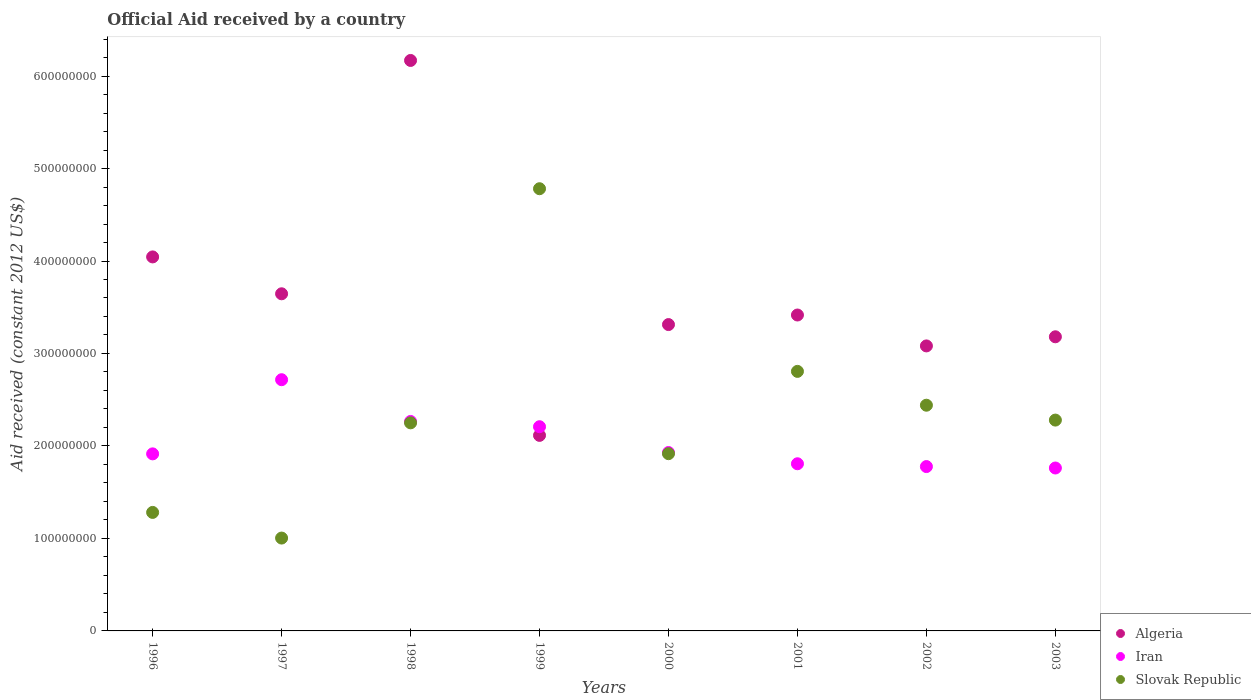How many different coloured dotlines are there?
Provide a short and direct response. 3. What is the net official aid received in Slovak Republic in 2003?
Your answer should be compact. 2.28e+08. Across all years, what is the maximum net official aid received in Slovak Republic?
Make the answer very short. 4.78e+08. Across all years, what is the minimum net official aid received in Algeria?
Your response must be concise. 2.11e+08. In which year was the net official aid received in Slovak Republic maximum?
Provide a succinct answer. 1999. What is the total net official aid received in Iran in the graph?
Offer a terse response. 1.64e+09. What is the difference between the net official aid received in Algeria in 1997 and that in 1999?
Provide a succinct answer. 1.53e+08. What is the difference between the net official aid received in Algeria in 1998 and the net official aid received in Iran in 2001?
Your response must be concise. 4.36e+08. What is the average net official aid received in Iran per year?
Offer a terse response. 2.05e+08. In the year 1998, what is the difference between the net official aid received in Algeria and net official aid received in Iran?
Offer a terse response. 3.90e+08. What is the ratio of the net official aid received in Algeria in 1998 to that in 2001?
Offer a terse response. 1.81. Is the net official aid received in Algeria in 1996 less than that in 2000?
Keep it short and to the point. No. What is the difference between the highest and the second highest net official aid received in Slovak Republic?
Provide a succinct answer. 1.98e+08. What is the difference between the highest and the lowest net official aid received in Algeria?
Provide a succinct answer. 4.05e+08. Is the sum of the net official aid received in Slovak Republic in 1998 and 2002 greater than the maximum net official aid received in Iran across all years?
Provide a short and direct response. Yes. Is the net official aid received in Slovak Republic strictly less than the net official aid received in Algeria over the years?
Ensure brevity in your answer.  No. Are the values on the major ticks of Y-axis written in scientific E-notation?
Ensure brevity in your answer.  No. How many legend labels are there?
Make the answer very short. 3. How are the legend labels stacked?
Offer a terse response. Vertical. What is the title of the graph?
Your answer should be very brief. Official Aid received by a country. What is the label or title of the Y-axis?
Keep it short and to the point. Aid received (constant 2012 US$). What is the Aid received (constant 2012 US$) in Algeria in 1996?
Your response must be concise. 4.04e+08. What is the Aid received (constant 2012 US$) of Iran in 1996?
Provide a short and direct response. 1.91e+08. What is the Aid received (constant 2012 US$) of Slovak Republic in 1996?
Your answer should be very brief. 1.28e+08. What is the Aid received (constant 2012 US$) of Algeria in 1997?
Give a very brief answer. 3.65e+08. What is the Aid received (constant 2012 US$) of Iran in 1997?
Give a very brief answer. 2.72e+08. What is the Aid received (constant 2012 US$) in Slovak Republic in 1997?
Give a very brief answer. 1.00e+08. What is the Aid received (constant 2012 US$) of Algeria in 1998?
Ensure brevity in your answer.  6.17e+08. What is the Aid received (constant 2012 US$) of Iran in 1998?
Keep it short and to the point. 2.27e+08. What is the Aid received (constant 2012 US$) of Slovak Republic in 1998?
Provide a succinct answer. 2.25e+08. What is the Aid received (constant 2012 US$) of Algeria in 1999?
Offer a terse response. 2.11e+08. What is the Aid received (constant 2012 US$) of Iran in 1999?
Give a very brief answer. 2.21e+08. What is the Aid received (constant 2012 US$) of Slovak Republic in 1999?
Your answer should be very brief. 4.78e+08. What is the Aid received (constant 2012 US$) in Algeria in 2000?
Offer a terse response. 3.31e+08. What is the Aid received (constant 2012 US$) in Iran in 2000?
Your response must be concise. 1.93e+08. What is the Aid received (constant 2012 US$) of Slovak Republic in 2000?
Make the answer very short. 1.92e+08. What is the Aid received (constant 2012 US$) in Algeria in 2001?
Your answer should be very brief. 3.42e+08. What is the Aid received (constant 2012 US$) in Iran in 2001?
Offer a terse response. 1.81e+08. What is the Aid received (constant 2012 US$) of Slovak Republic in 2001?
Make the answer very short. 2.81e+08. What is the Aid received (constant 2012 US$) in Algeria in 2002?
Provide a succinct answer. 3.08e+08. What is the Aid received (constant 2012 US$) in Iran in 2002?
Keep it short and to the point. 1.78e+08. What is the Aid received (constant 2012 US$) in Slovak Republic in 2002?
Make the answer very short. 2.44e+08. What is the Aid received (constant 2012 US$) of Algeria in 2003?
Ensure brevity in your answer.  3.18e+08. What is the Aid received (constant 2012 US$) in Iran in 2003?
Provide a succinct answer. 1.76e+08. What is the Aid received (constant 2012 US$) in Slovak Republic in 2003?
Ensure brevity in your answer.  2.28e+08. Across all years, what is the maximum Aid received (constant 2012 US$) of Algeria?
Ensure brevity in your answer.  6.17e+08. Across all years, what is the maximum Aid received (constant 2012 US$) of Iran?
Give a very brief answer. 2.72e+08. Across all years, what is the maximum Aid received (constant 2012 US$) in Slovak Republic?
Provide a succinct answer. 4.78e+08. Across all years, what is the minimum Aid received (constant 2012 US$) of Algeria?
Your answer should be compact. 2.11e+08. Across all years, what is the minimum Aid received (constant 2012 US$) of Iran?
Offer a terse response. 1.76e+08. Across all years, what is the minimum Aid received (constant 2012 US$) of Slovak Republic?
Your response must be concise. 1.00e+08. What is the total Aid received (constant 2012 US$) in Algeria in the graph?
Your response must be concise. 2.90e+09. What is the total Aid received (constant 2012 US$) in Iran in the graph?
Your answer should be compact. 1.64e+09. What is the total Aid received (constant 2012 US$) in Slovak Republic in the graph?
Ensure brevity in your answer.  1.88e+09. What is the difference between the Aid received (constant 2012 US$) in Algeria in 1996 and that in 1997?
Ensure brevity in your answer.  3.99e+07. What is the difference between the Aid received (constant 2012 US$) of Iran in 1996 and that in 1997?
Provide a short and direct response. -8.02e+07. What is the difference between the Aid received (constant 2012 US$) of Slovak Republic in 1996 and that in 1997?
Your answer should be compact. 2.77e+07. What is the difference between the Aid received (constant 2012 US$) in Algeria in 1996 and that in 1998?
Offer a very short reply. -2.12e+08. What is the difference between the Aid received (constant 2012 US$) in Iran in 1996 and that in 1998?
Offer a terse response. -3.51e+07. What is the difference between the Aid received (constant 2012 US$) in Slovak Republic in 1996 and that in 1998?
Make the answer very short. -9.69e+07. What is the difference between the Aid received (constant 2012 US$) in Algeria in 1996 and that in 1999?
Provide a short and direct response. 1.93e+08. What is the difference between the Aid received (constant 2012 US$) in Iran in 1996 and that in 1999?
Ensure brevity in your answer.  -2.94e+07. What is the difference between the Aid received (constant 2012 US$) in Slovak Republic in 1996 and that in 1999?
Keep it short and to the point. -3.50e+08. What is the difference between the Aid received (constant 2012 US$) in Algeria in 1996 and that in 2000?
Your answer should be compact. 7.32e+07. What is the difference between the Aid received (constant 2012 US$) in Iran in 1996 and that in 2000?
Provide a succinct answer. -1.48e+06. What is the difference between the Aid received (constant 2012 US$) in Slovak Republic in 1996 and that in 2000?
Give a very brief answer. -6.35e+07. What is the difference between the Aid received (constant 2012 US$) in Algeria in 1996 and that in 2001?
Make the answer very short. 6.28e+07. What is the difference between the Aid received (constant 2012 US$) of Iran in 1996 and that in 2001?
Make the answer very short. 1.07e+07. What is the difference between the Aid received (constant 2012 US$) of Slovak Republic in 1996 and that in 2001?
Your response must be concise. -1.53e+08. What is the difference between the Aid received (constant 2012 US$) of Algeria in 1996 and that in 2002?
Your response must be concise. 9.62e+07. What is the difference between the Aid received (constant 2012 US$) in Iran in 1996 and that in 2002?
Your answer should be very brief. 1.37e+07. What is the difference between the Aid received (constant 2012 US$) of Slovak Republic in 1996 and that in 2002?
Your response must be concise. -1.16e+08. What is the difference between the Aid received (constant 2012 US$) in Algeria in 1996 and that in 2003?
Offer a terse response. 8.64e+07. What is the difference between the Aid received (constant 2012 US$) of Iran in 1996 and that in 2003?
Ensure brevity in your answer.  1.53e+07. What is the difference between the Aid received (constant 2012 US$) in Slovak Republic in 1996 and that in 2003?
Provide a succinct answer. -9.98e+07. What is the difference between the Aid received (constant 2012 US$) in Algeria in 1997 and that in 1998?
Ensure brevity in your answer.  -2.52e+08. What is the difference between the Aid received (constant 2012 US$) in Iran in 1997 and that in 1998?
Provide a short and direct response. 4.51e+07. What is the difference between the Aid received (constant 2012 US$) of Slovak Republic in 1997 and that in 1998?
Provide a succinct answer. -1.25e+08. What is the difference between the Aid received (constant 2012 US$) of Algeria in 1997 and that in 1999?
Your response must be concise. 1.53e+08. What is the difference between the Aid received (constant 2012 US$) in Iran in 1997 and that in 1999?
Ensure brevity in your answer.  5.08e+07. What is the difference between the Aid received (constant 2012 US$) in Slovak Republic in 1997 and that in 1999?
Ensure brevity in your answer.  -3.78e+08. What is the difference between the Aid received (constant 2012 US$) in Algeria in 1997 and that in 2000?
Offer a very short reply. 3.33e+07. What is the difference between the Aid received (constant 2012 US$) of Iran in 1997 and that in 2000?
Provide a succinct answer. 7.87e+07. What is the difference between the Aid received (constant 2012 US$) in Slovak Republic in 1997 and that in 2000?
Your answer should be compact. -9.12e+07. What is the difference between the Aid received (constant 2012 US$) in Algeria in 1997 and that in 2001?
Keep it short and to the point. 2.30e+07. What is the difference between the Aid received (constant 2012 US$) in Iran in 1997 and that in 2001?
Offer a very short reply. 9.09e+07. What is the difference between the Aid received (constant 2012 US$) of Slovak Republic in 1997 and that in 2001?
Ensure brevity in your answer.  -1.80e+08. What is the difference between the Aid received (constant 2012 US$) of Algeria in 1997 and that in 2002?
Keep it short and to the point. 5.64e+07. What is the difference between the Aid received (constant 2012 US$) in Iran in 1997 and that in 2002?
Your answer should be compact. 9.39e+07. What is the difference between the Aid received (constant 2012 US$) of Slovak Republic in 1997 and that in 2002?
Make the answer very short. -1.44e+08. What is the difference between the Aid received (constant 2012 US$) in Algeria in 1997 and that in 2003?
Ensure brevity in your answer.  4.65e+07. What is the difference between the Aid received (constant 2012 US$) in Iran in 1997 and that in 2003?
Ensure brevity in your answer.  9.55e+07. What is the difference between the Aid received (constant 2012 US$) in Slovak Republic in 1997 and that in 2003?
Offer a very short reply. -1.28e+08. What is the difference between the Aid received (constant 2012 US$) of Algeria in 1998 and that in 1999?
Offer a very short reply. 4.05e+08. What is the difference between the Aid received (constant 2012 US$) in Iran in 1998 and that in 1999?
Your response must be concise. 5.70e+06. What is the difference between the Aid received (constant 2012 US$) of Slovak Republic in 1998 and that in 1999?
Your answer should be very brief. -2.53e+08. What is the difference between the Aid received (constant 2012 US$) of Algeria in 1998 and that in 2000?
Provide a succinct answer. 2.86e+08. What is the difference between the Aid received (constant 2012 US$) in Iran in 1998 and that in 2000?
Provide a short and direct response. 3.36e+07. What is the difference between the Aid received (constant 2012 US$) in Slovak Republic in 1998 and that in 2000?
Provide a short and direct response. 3.33e+07. What is the difference between the Aid received (constant 2012 US$) of Algeria in 1998 and that in 2001?
Your answer should be compact. 2.75e+08. What is the difference between the Aid received (constant 2012 US$) of Iran in 1998 and that in 2001?
Ensure brevity in your answer.  4.58e+07. What is the difference between the Aid received (constant 2012 US$) of Slovak Republic in 1998 and that in 2001?
Offer a terse response. -5.56e+07. What is the difference between the Aid received (constant 2012 US$) of Algeria in 1998 and that in 2002?
Keep it short and to the point. 3.09e+08. What is the difference between the Aid received (constant 2012 US$) in Iran in 1998 and that in 2002?
Offer a very short reply. 4.88e+07. What is the difference between the Aid received (constant 2012 US$) in Slovak Republic in 1998 and that in 2002?
Ensure brevity in your answer.  -1.91e+07. What is the difference between the Aid received (constant 2012 US$) in Algeria in 1998 and that in 2003?
Offer a very short reply. 2.99e+08. What is the difference between the Aid received (constant 2012 US$) of Iran in 1998 and that in 2003?
Provide a short and direct response. 5.03e+07. What is the difference between the Aid received (constant 2012 US$) of Slovak Republic in 1998 and that in 2003?
Give a very brief answer. -2.98e+06. What is the difference between the Aid received (constant 2012 US$) of Algeria in 1999 and that in 2000?
Make the answer very short. -1.20e+08. What is the difference between the Aid received (constant 2012 US$) in Iran in 1999 and that in 2000?
Make the answer very short. 2.79e+07. What is the difference between the Aid received (constant 2012 US$) of Slovak Republic in 1999 and that in 2000?
Make the answer very short. 2.86e+08. What is the difference between the Aid received (constant 2012 US$) of Algeria in 1999 and that in 2001?
Make the answer very short. -1.30e+08. What is the difference between the Aid received (constant 2012 US$) in Iran in 1999 and that in 2001?
Offer a very short reply. 4.01e+07. What is the difference between the Aid received (constant 2012 US$) in Slovak Republic in 1999 and that in 2001?
Your response must be concise. 1.98e+08. What is the difference between the Aid received (constant 2012 US$) of Algeria in 1999 and that in 2002?
Offer a very short reply. -9.67e+07. What is the difference between the Aid received (constant 2012 US$) in Iran in 1999 and that in 2002?
Provide a succinct answer. 4.31e+07. What is the difference between the Aid received (constant 2012 US$) of Slovak Republic in 1999 and that in 2002?
Your answer should be very brief. 2.34e+08. What is the difference between the Aid received (constant 2012 US$) in Algeria in 1999 and that in 2003?
Your answer should be very brief. -1.07e+08. What is the difference between the Aid received (constant 2012 US$) in Iran in 1999 and that in 2003?
Ensure brevity in your answer.  4.46e+07. What is the difference between the Aid received (constant 2012 US$) of Slovak Republic in 1999 and that in 2003?
Offer a very short reply. 2.50e+08. What is the difference between the Aid received (constant 2012 US$) of Algeria in 2000 and that in 2001?
Your answer should be very brief. -1.03e+07. What is the difference between the Aid received (constant 2012 US$) in Iran in 2000 and that in 2001?
Your answer should be compact. 1.22e+07. What is the difference between the Aid received (constant 2012 US$) of Slovak Republic in 2000 and that in 2001?
Your answer should be very brief. -8.90e+07. What is the difference between the Aid received (constant 2012 US$) of Algeria in 2000 and that in 2002?
Your answer should be very brief. 2.31e+07. What is the difference between the Aid received (constant 2012 US$) in Iran in 2000 and that in 2002?
Offer a very short reply. 1.52e+07. What is the difference between the Aid received (constant 2012 US$) of Slovak Republic in 2000 and that in 2002?
Keep it short and to the point. -5.24e+07. What is the difference between the Aid received (constant 2012 US$) in Algeria in 2000 and that in 2003?
Make the answer very short. 1.32e+07. What is the difference between the Aid received (constant 2012 US$) of Iran in 2000 and that in 2003?
Offer a terse response. 1.68e+07. What is the difference between the Aid received (constant 2012 US$) in Slovak Republic in 2000 and that in 2003?
Provide a short and direct response. -3.63e+07. What is the difference between the Aid received (constant 2012 US$) in Algeria in 2001 and that in 2002?
Give a very brief answer. 3.34e+07. What is the difference between the Aid received (constant 2012 US$) of Iran in 2001 and that in 2002?
Offer a terse response. 3.03e+06. What is the difference between the Aid received (constant 2012 US$) of Slovak Republic in 2001 and that in 2002?
Offer a very short reply. 3.66e+07. What is the difference between the Aid received (constant 2012 US$) in Algeria in 2001 and that in 2003?
Your answer should be compact. 2.36e+07. What is the difference between the Aid received (constant 2012 US$) of Iran in 2001 and that in 2003?
Your answer should be compact. 4.58e+06. What is the difference between the Aid received (constant 2012 US$) in Slovak Republic in 2001 and that in 2003?
Offer a very short reply. 5.27e+07. What is the difference between the Aid received (constant 2012 US$) in Algeria in 2002 and that in 2003?
Your answer should be compact. -9.87e+06. What is the difference between the Aid received (constant 2012 US$) of Iran in 2002 and that in 2003?
Keep it short and to the point. 1.55e+06. What is the difference between the Aid received (constant 2012 US$) in Slovak Republic in 2002 and that in 2003?
Offer a terse response. 1.61e+07. What is the difference between the Aid received (constant 2012 US$) of Algeria in 1996 and the Aid received (constant 2012 US$) of Iran in 1997?
Offer a very short reply. 1.33e+08. What is the difference between the Aid received (constant 2012 US$) of Algeria in 1996 and the Aid received (constant 2012 US$) of Slovak Republic in 1997?
Give a very brief answer. 3.04e+08. What is the difference between the Aid received (constant 2012 US$) of Iran in 1996 and the Aid received (constant 2012 US$) of Slovak Republic in 1997?
Offer a very short reply. 9.10e+07. What is the difference between the Aid received (constant 2012 US$) in Algeria in 1996 and the Aid received (constant 2012 US$) in Iran in 1998?
Ensure brevity in your answer.  1.78e+08. What is the difference between the Aid received (constant 2012 US$) in Algeria in 1996 and the Aid received (constant 2012 US$) in Slovak Republic in 1998?
Give a very brief answer. 1.79e+08. What is the difference between the Aid received (constant 2012 US$) in Iran in 1996 and the Aid received (constant 2012 US$) in Slovak Republic in 1998?
Offer a very short reply. -3.36e+07. What is the difference between the Aid received (constant 2012 US$) of Algeria in 1996 and the Aid received (constant 2012 US$) of Iran in 1999?
Your answer should be very brief. 1.84e+08. What is the difference between the Aid received (constant 2012 US$) in Algeria in 1996 and the Aid received (constant 2012 US$) in Slovak Republic in 1999?
Offer a terse response. -7.37e+07. What is the difference between the Aid received (constant 2012 US$) of Iran in 1996 and the Aid received (constant 2012 US$) of Slovak Republic in 1999?
Make the answer very short. -2.87e+08. What is the difference between the Aid received (constant 2012 US$) of Algeria in 1996 and the Aid received (constant 2012 US$) of Iran in 2000?
Provide a succinct answer. 2.11e+08. What is the difference between the Aid received (constant 2012 US$) in Algeria in 1996 and the Aid received (constant 2012 US$) in Slovak Republic in 2000?
Make the answer very short. 2.13e+08. What is the difference between the Aid received (constant 2012 US$) of Iran in 1996 and the Aid received (constant 2012 US$) of Slovak Republic in 2000?
Provide a succinct answer. -2.10e+05. What is the difference between the Aid received (constant 2012 US$) in Algeria in 1996 and the Aid received (constant 2012 US$) in Iran in 2001?
Give a very brief answer. 2.24e+08. What is the difference between the Aid received (constant 2012 US$) in Algeria in 1996 and the Aid received (constant 2012 US$) in Slovak Republic in 2001?
Make the answer very short. 1.24e+08. What is the difference between the Aid received (constant 2012 US$) in Iran in 1996 and the Aid received (constant 2012 US$) in Slovak Republic in 2001?
Offer a very short reply. -8.92e+07. What is the difference between the Aid received (constant 2012 US$) of Algeria in 1996 and the Aid received (constant 2012 US$) of Iran in 2002?
Give a very brief answer. 2.27e+08. What is the difference between the Aid received (constant 2012 US$) in Algeria in 1996 and the Aid received (constant 2012 US$) in Slovak Republic in 2002?
Make the answer very short. 1.60e+08. What is the difference between the Aid received (constant 2012 US$) of Iran in 1996 and the Aid received (constant 2012 US$) of Slovak Republic in 2002?
Your response must be concise. -5.26e+07. What is the difference between the Aid received (constant 2012 US$) in Algeria in 1996 and the Aid received (constant 2012 US$) in Iran in 2003?
Ensure brevity in your answer.  2.28e+08. What is the difference between the Aid received (constant 2012 US$) of Algeria in 1996 and the Aid received (constant 2012 US$) of Slovak Republic in 2003?
Your answer should be very brief. 1.76e+08. What is the difference between the Aid received (constant 2012 US$) in Iran in 1996 and the Aid received (constant 2012 US$) in Slovak Republic in 2003?
Your answer should be compact. -3.65e+07. What is the difference between the Aid received (constant 2012 US$) of Algeria in 1997 and the Aid received (constant 2012 US$) of Iran in 1998?
Provide a short and direct response. 1.38e+08. What is the difference between the Aid received (constant 2012 US$) of Algeria in 1997 and the Aid received (constant 2012 US$) of Slovak Republic in 1998?
Your answer should be very brief. 1.40e+08. What is the difference between the Aid received (constant 2012 US$) of Iran in 1997 and the Aid received (constant 2012 US$) of Slovak Republic in 1998?
Offer a terse response. 4.66e+07. What is the difference between the Aid received (constant 2012 US$) in Algeria in 1997 and the Aid received (constant 2012 US$) in Iran in 1999?
Provide a succinct answer. 1.44e+08. What is the difference between the Aid received (constant 2012 US$) of Algeria in 1997 and the Aid received (constant 2012 US$) of Slovak Republic in 1999?
Your answer should be very brief. -1.14e+08. What is the difference between the Aid received (constant 2012 US$) of Iran in 1997 and the Aid received (constant 2012 US$) of Slovak Republic in 1999?
Provide a succinct answer. -2.07e+08. What is the difference between the Aid received (constant 2012 US$) of Algeria in 1997 and the Aid received (constant 2012 US$) of Iran in 2000?
Keep it short and to the point. 1.72e+08. What is the difference between the Aid received (constant 2012 US$) in Algeria in 1997 and the Aid received (constant 2012 US$) in Slovak Republic in 2000?
Offer a very short reply. 1.73e+08. What is the difference between the Aid received (constant 2012 US$) in Iran in 1997 and the Aid received (constant 2012 US$) in Slovak Republic in 2000?
Provide a short and direct response. 8.00e+07. What is the difference between the Aid received (constant 2012 US$) of Algeria in 1997 and the Aid received (constant 2012 US$) of Iran in 2001?
Make the answer very short. 1.84e+08. What is the difference between the Aid received (constant 2012 US$) of Algeria in 1997 and the Aid received (constant 2012 US$) of Slovak Republic in 2001?
Provide a succinct answer. 8.39e+07. What is the difference between the Aid received (constant 2012 US$) in Iran in 1997 and the Aid received (constant 2012 US$) in Slovak Republic in 2001?
Keep it short and to the point. -9.01e+06. What is the difference between the Aid received (constant 2012 US$) in Algeria in 1997 and the Aid received (constant 2012 US$) in Iran in 2002?
Your answer should be very brief. 1.87e+08. What is the difference between the Aid received (constant 2012 US$) in Algeria in 1997 and the Aid received (constant 2012 US$) in Slovak Republic in 2002?
Make the answer very short. 1.20e+08. What is the difference between the Aid received (constant 2012 US$) of Iran in 1997 and the Aid received (constant 2012 US$) of Slovak Republic in 2002?
Provide a short and direct response. 2.76e+07. What is the difference between the Aid received (constant 2012 US$) of Algeria in 1997 and the Aid received (constant 2012 US$) of Iran in 2003?
Offer a terse response. 1.88e+08. What is the difference between the Aid received (constant 2012 US$) of Algeria in 1997 and the Aid received (constant 2012 US$) of Slovak Republic in 2003?
Provide a succinct answer. 1.37e+08. What is the difference between the Aid received (constant 2012 US$) of Iran in 1997 and the Aid received (constant 2012 US$) of Slovak Republic in 2003?
Give a very brief answer. 4.37e+07. What is the difference between the Aid received (constant 2012 US$) in Algeria in 1998 and the Aid received (constant 2012 US$) in Iran in 1999?
Offer a very short reply. 3.96e+08. What is the difference between the Aid received (constant 2012 US$) in Algeria in 1998 and the Aid received (constant 2012 US$) in Slovak Republic in 1999?
Provide a short and direct response. 1.39e+08. What is the difference between the Aid received (constant 2012 US$) in Iran in 1998 and the Aid received (constant 2012 US$) in Slovak Republic in 1999?
Your answer should be compact. -2.52e+08. What is the difference between the Aid received (constant 2012 US$) in Algeria in 1998 and the Aid received (constant 2012 US$) in Iran in 2000?
Your response must be concise. 4.24e+08. What is the difference between the Aid received (constant 2012 US$) in Algeria in 1998 and the Aid received (constant 2012 US$) in Slovak Republic in 2000?
Your answer should be compact. 4.25e+08. What is the difference between the Aid received (constant 2012 US$) in Iran in 1998 and the Aid received (constant 2012 US$) in Slovak Republic in 2000?
Ensure brevity in your answer.  3.48e+07. What is the difference between the Aid received (constant 2012 US$) in Algeria in 1998 and the Aid received (constant 2012 US$) in Iran in 2001?
Ensure brevity in your answer.  4.36e+08. What is the difference between the Aid received (constant 2012 US$) of Algeria in 1998 and the Aid received (constant 2012 US$) of Slovak Republic in 2001?
Make the answer very short. 3.36e+08. What is the difference between the Aid received (constant 2012 US$) of Iran in 1998 and the Aid received (constant 2012 US$) of Slovak Republic in 2001?
Your answer should be very brief. -5.41e+07. What is the difference between the Aid received (constant 2012 US$) in Algeria in 1998 and the Aid received (constant 2012 US$) in Iran in 2002?
Your answer should be very brief. 4.39e+08. What is the difference between the Aid received (constant 2012 US$) of Algeria in 1998 and the Aid received (constant 2012 US$) of Slovak Republic in 2002?
Make the answer very short. 3.73e+08. What is the difference between the Aid received (constant 2012 US$) in Iran in 1998 and the Aid received (constant 2012 US$) in Slovak Republic in 2002?
Ensure brevity in your answer.  -1.76e+07. What is the difference between the Aid received (constant 2012 US$) in Algeria in 1998 and the Aid received (constant 2012 US$) in Iran in 2003?
Your answer should be very brief. 4.41e+08. What is the difference between the Aid received (constant 2012 US$) of Algeria in 1998 and the Aid received (constant 2012 US$) of Slovak Republic in 2003?
Keep it short and to the point. 3.89e+08. What is the difference between the Aid received (constant 2012 US$) in Iran in 1998 and the Aid received (constant 2012 US$) in Slovak Republic in 2003?
Provide a short and direct response. -1.47e+06. What is the difference between the Aid received (constant 2012 US$) in Algeria in 1999 and the Aid received (constant 2012 US$) in Iran in 2000?
Offer a terse response. 1.85e+07. What is the difference between the Aid received (constant 2012 US$) in Algeria in 1999 and the Aid received (constant 2012 US$) in Slovak Republic in 2000?
Your response must be concise. 1.98e+07. What is the difference between the Aid received (constant 2012 US$) in Iran in 1999 and the Aid received (constant 2012 US$) in Slovak Republic in 2000?
Offer a very short reply. 2.92e+07. What is the difference between the Aid received (constant 2012 US$) in Algeria in 1999 and the Aid received (constant 2012 US$) in Iran in 2001?
Your answer should be very brief. 3.07e+07. What is the difference between the Aid received (constant 2012 US$) of Algeria in 1999 and the Aid received (constant 2012 US$) of Slovak Republic in 2001?
Your answer should be very brief. -6.92e+07. What is the difference between the Aid received (constant 2012 US$) in Iran in 1999 and the Aid received (constant 2012 US$) in Slovak Republic in 2001?
Ensure brevity in your answer.  -5.98e+07. What is the difference between the Aid received (constant 2012 US$) in Algeria in 1999 and the Aid received (constant 2012 US$) in Iran in 2002?
Ensure brevity in your answer.  3.37e+07. What is the difference between the Aid received (constant 2012 US$) in Algeria in 1999 and the Aid received (constant 2012 US$) in Slovak Republic in 2002?
Provide a short and direct response. -3.26e+07. What is the difference between the Aid received (constant 2012 US$) in Iran in 1999 and the Aid received (constant 2012 US$) in Slovak Republic in 2002?
Give a very brief answer. -2.32e+07. What is the difference between the Aid received (constant 2012 US$) in Algeria in 1999 and the Aid received (constant 2012 US$) in Iran in 2003?
Your answer should be compact. 3.53e+07. What is the difference between the Aid received (constant 2012 US$) of Algeria in 1999 and the Aid received (constant 2012 US$) of Slovak Republic in 2003?
Your answer should be very brief. -1.65e+07. What is the difference between the Aid received (constant 2012 US$) in Iran in 1999 and the Aid received (constant 2012 US$) in Slovak Republic in 2003?
Ensure brevity in your answer.  -7.17e+06. What is the difference between the Aid received (constant 2012 US$) of Algeria in 2000 and the Aid received (constant 2012 US$) of Iran in 2001?
Your answer should be very brief. 1.51e+08. What is the difference between the Aid received (constant 2012 US$) of Algeria in 2000 and the Aid received (constant 2012 US$) of Slovak Republic in 2001?
Keep it short and to the point. 5.06e+07. What is the difference between the Aid received (constant 2012 US$) in Iran in 2000 and the Aid received (constant 2012 US$) in Slovak Republic in 2001?
Ensure brevity in your answer.  -8.77e+07. What is the difference between the Aid received (constant 2012 US$) of Algeria in 2000 and the Aid received (constant 2012 US$) of Iran in 2002?
Give a very brief answer. 1.54e+08. What is the difference between the Aid received (constant 2012 US$) in Algeria in 2000 and the Aid received (constant 2012 US$) in Slovak Republic in 2002?
Make the answer very short. 8.72e+07. What is the difference between the Aid received (constant 2012 US$) in Iran in 2000 and the Aid received (constant 2012 US$) in Slovak Republic in 2002?
Offer a very short reply. -5.11e+07. What is the difference between the Aid received (constant 2012 US$) of Algeria in 2000 and the Aid received (constant 2012 US$) of Iran in 2003?
Ensure brevity in your answer.  1.55e+08. What is the difference between the Aid received (constant 2012 US$) of Algeria in 2000 and the Aid received (constant 2012 US$) of Slovak Republic in 2003?
Give a very brief answer. 1.03e+08. What is the difference between the Aid received (constant 2012 US$) in Iran in 2000 and the Aid received (constant 2012 US$) in Slovak Republic in 2003?
Your answer should be compact. -3.50e+07. What is the difference between the Aid received (constant 2012 US$) of Algeria in 2001 and the Aid received (constant 2012 US$) of Iran in 2002?
Your response must be concise. 1.64e+08. What is the difference between the Aid received (constant 2012 US$) of Algeria in 2001 and the Aid received (constant 2012 US$) of Slovak Republic in 2002?
Your response must be concise. 9.75e+07. What is the difference between the Aid received (constant 2012 US$) of Iran in 2001 and the Aid received (constant 2012 US$) of Slovak Republic in 2002?
Give a very brief answer. -6.33e+07. What is the difference between the Aid received (constant 2012 US$) in Algeria in 2001 and the Aid received (constant 2012 US$) in Iran in 2003?
Your answer should be very brief. 1.65e+08. What is the difference between the Aid received (constant 2012 US$) of Algeria in 2001 and the Aid received (constant 2012 US$) of Slovak Republic in 2003?
Give a very brief answer. 1.14e+08. What is the difference between the Aid received (constant 2012 US$) of Iran in 2001 and the Aid received (constant 2012 US$) of Slovak Republic in 2003?
Give a very brief answer. -4.72e+07. What is the difference between the Aid received (constant 2012 US$) of Algeria in 2002 and the Aid received (constant 2012 US$) of Iran in 2003?
Keep it short and to the point. 1.32e+08. What is the difference between the Aid received (constant 2012 US$) in Algeria in 2002 and the Aid received (constant 2012 US$) in Slovak Republic in 2003?
Your response must be concise. 8.02e+07. What is the difference between the Aid received (constant 2012 US$) of Iran in 2002 and the Aid received (constant 2012 US$) of Slovak Republic in 2003?
Provide a succinct answer. -5.03e+07. What is the average Aid received (constant 2012 US$) in Algeria per year?
Ensure brevity in your answer.  3.62e+08. What is the average Aid received (constant 2012 US$) in Iran per year?
Provide a succinct answer. 2.05e+08. What is the average Aid received (constant 2012 US$) of Slovak Republic per year?
Your answer should be compact. 2.35e+08. In the year 1996, what is the difference between the Aid received (constant 2012 US$) in Algeria and Aid received (constant 2012 US$) in Iran?
Offer a terse response. 2.13e+08. In the year 1996, what is the difference between the Aid received (constant 2012 US$) of Algeria and Aid received (constant 2012 US$) of Slovak Republic?
Provide a succinct answer. 2.76e+08. In the year 1996, what is the difference between the Aid received (constant 2012 US$) of Iran and Aid received (constant 2012 US$) of Slovak Republic?
Keep it short and to the point. 6.33e+07. In the year 1997, what is the difference between the Aid received (constant 2012 US$) in Algeria and Aid received (constant 2012 US$) in Iran?
Offer a terse response. 9.29e+07. In the year 1997, what is the difference between the Aid received (constant 2012 US$) of Algeria and Aid received (constant 2012 US$) of Slovak Republic?
Provide a succinct answer. 2.64e+08. In the year 1997, what is the difference between the Aid received (constant 2012 US$) in Iran and Aid received (constant 2012 US$) in Slovak Republic?
Your answer should be very brief. 1.71e+08. In the year 1998, what is the difference between the Aid received (constant 2012 US$) in Algeria and Aid received (constant 2012 US$) in Iran?
Your response must be concise. 3.90e+08. In the year 1998, what is the difference between the Aid received (constant 2012 US$) of Algeria and Aid received (constant 2012 US$) of Slovak Republic?
Keep it short and to the point. 3.92e+08. In the year 1998, what is the difference between the Aid received (constant 2012 US$) in Iran and Aid received (constant 2012 US$) in Slovak Republic?
Offer a very short reply. 1.51e+06. In the year 1999, what is the difference between the Aid received (constant 2012 US$) in Algeria and Aid received (constant 2012 US$) in Iran?
Your answer should be very brief. -9.37e+06. In the year 1999, what is the difference between the Aid received (constant 2012 US$) in Algeria and Aid received (constant 2012 US$) in Slovak Republic?
Ensure brevity in your answer.  -2.67e+08. In the year 1999, what is the difference between the Aid received (constant 2012 US$) of Iran and Aid received (constant 2012 US$) of Slovak Republic?
Provide a succinct answer. -2.57e+08. In the year 2000, what is the difference between the Aid received (constant 2012 US$) of Algeria and Aid received (constant 2012 US$) of Iran?
Your response must be concise. 1.38e+08. In the year 2000, what is the difference between the Aid received (constant 2012 US$) in Algeria and Aid received (constant 2012 US$) in Slovak Republic?
Keep it short and to the point. 1.40e+08. In the year 2000, what is the difference between the Aid received (constant 2012 US$) in Iran and Aid received (constant 2012 US$) in Slovak Republic?
Provide a succinct answer. 1.27e+06. In the year 2001, what is the difference between the Aid received (constant 2012 US$) of Algeria and Aid received (constant 2012 US$) of Iran?
Provide a short and direct response. 1.61e+08. In the year 2001, what is the difference between the Aid received (constant 2012 US$) in Algeria and Aid received (constant 2012 US$) in Slovak Republic?
Keep it short and to the point. 6.10e+07. In the year 2001, what is the difference between the Aid received (constant 2012 US$) of Iran and Aid received (constant 2012 US$) of Slovak Republic?
Ensure brevity in your answer.  -9.99e+07. In the year 2002, what is the difference between the Aid received (constant 2012 US$) in Algeria and Aid received (constant 2012 US$) in Iran?
Your answer should be compact. 1.30e+08. In the year 2002, what is the difference between the Aid received (constant 2012 US$) in Algeria and Aid received (constant 2012 US$) in Slovak Republic?
Provide a short and direct response. 6.41e+07. In the year 2002, what is the difference between the Aid received (constant 2012 US$) in Iran and Aid received (constant 2012 US$) in Slovak Republic?
Keep it short and to the point. -6.63e+07. In the year 2003, what is the difference between the Aid received (constant 2012 US$) of Algeria and Aid received (constant 2012 US$) of Iran?
Your answer should be very brief. 1.42e+08. In the year 2003, what is the difference between the Aid received (constant 2012 US$) of Algeria and Aid received (constant 2012 US$) of Slovak Republic?
Your answer should be compact. 9.01e+07. In the year 2003, what is the difference between the Aid received (constant 2012 US$) of Iran and Aid received (constant 2012 US$) of Slovak Republic?
Offer a terse response. -5.18e+07. What is the ratio of the Aid received (constant 2012 US$) in Algeria in 1996 to that in 1997?
Make the answer very short. 1.11. What is the ratio of the Aid received (constant 2012 US$) of Iran in 1996 to that in 1997?
Your answer should be compact. 0.7. What is the ratio of the Aid received (constant 2012 US$) of Slovak Republic in 1996 to that in 1997?
Your answer should be compact. 1.28. What is the ratio of the Aid received (constant 2012 US$) in Algeria in 1996 to that in 1998?
Provide a succinct answer. 0.66. What is the ratio of the Aid received (constant 2012 US$) in Iran in 1996 to that in 1998?
Ensure brevity in your answer.  0.85. What is the ratio of the Aid received (constant 2012 US$) in Slovak Republic in 1996 to that in 1998?
Offer a terse response. 0.57. What is the ratio of the Aid received (constant 2012 US$) of Algeria in 1996 to that in 1999?
Your response must be concise. 1.91. What is the ratio of the Aid received (constant 2012 US$) of Iran in 1996 to that in 1999?
Keep it short and to the point. 0.87. What is the ratio of the Aid received (constant 2012 US$) in Slovak Republic in 1996 to that in 1999?
Make the answer very short. 0.27. What is the ratio of the Aid received (constant 2012 US$) in Algeria in 1996 to that in 2000?
Give a very brief answer. 1.22. What is the ratio of the Aid received (constant 2012 US$) in Iran in 1996 to that in 2000?
Ensure brevity in your answer.  0.99. What is the ratio of the Aid received (constant 2012 US$) of Slovak Republic in 1996 to that in 2000?
Provide a succinct answer. 0.67. What is the ratio of the Aid received (constant 2012 US$) of Algeria in 1996 to that in 2001?
Offer a terse response. 1.18. What is the ratio of the Aid received (constant 2012 US$) in Iran in 1996 to that in 2001?
Provide a short and direct response. 1.06. What is the ratio of the Aid received (constant 2012 US$) of Slovak Republic in 1996 to that in 2001?
Ensure brevity in your answer.  0.46. What is the ratio of the Aid received (constant 2012 US$) in Algeria in 1996 to that in 2002?
Ensure brevity in your answer.  1.31. What is the ratio of the Aid received (constant 2012 US$) in Iran in 1996 to that in 2002?
Provide a short and direct response. 1.08. What is the ratio of the Aid received (constant 2012 US$) of Slovak Republic in 1996 to that in 2002?
Provide a succinct answer. 0.53. What is the ratio of the Aid received (constant 2012 US$) in Algeria in 1996 to that in 2003?
Your answer should be compact. 1.27. What is the ratio of the Aid received (constant 2012 US$) in Iran in 1996 to that in 2003?
Your response must be concise. 1.09. What is the ratio of the Aid received (constant 2012 US$) in Slovak Republic in 1996 to that in 2003?
Make the answer very short. 0.56. What is the ratio of the Aid received (constant 2012 US$) of Algeria in 1997 to that in 1998?
Your answer should be compact. 0.59. What is the ratio of the Aid received (constant 2012 US$) in Iran in 1997 to that in 1998?
Ensure brevity in your answer.  1.2. What is the ratio of the Aid received (constant 2012 US$) in Slovak Republic in 1997 to that in 1998?
Provide a short and direct response. 0.45. What is the ratio of the Aid received (constant 2012 US$) of Algeria in 1997 to that in 1999?
Keep it short and to the point. 1.72. What is the ratio of the Aid received (constant 2012 US$) in Iran in 1997 to that in 1999?
Your answer should be very brief. 1.23. What is the ratio of the Aid received (constant 2012 US$) of Slovak Republic in 1997 to that in 1999?
Ensure brevity in your answer.  0.21. What is the ratio of the Aid received (constant 2012 US$) of Algeria in 1997 to that in 2000?
Keep it short and to the point. 1.1. What is the ratio of the Aid received (constant 2012 US$) of Iran in 1997 to that in 2000?
Your answer should be compact. 1.41. What is the ratio of the Aid received (constant 2012 US$) of Slovak Republic in 1997 to that in 2000?
Your answer should be compact. 0.52. What is the ratio of the Aid received (constant 2012 US$) of Algeria in 1997 to that in 2001?
Ensure brevity in your answer.  1.07. What is the ratio of the Aid received (constant 2012 US$) in Iran in 1997 to that in 2001?
Give a very brief answer. 1.5. What is the ratio of the Aid received (constant 2012 US$) in Slovak Republic in 1997 to that in 2001?
Keep it short and to the point. 0.36. What is the ratio of the Aid received (constant 2012 US$) of Algeria in 1997 to that in 2002?
Provide a short and direct response. 1.18. What is the ratio of the Aid received (constant 2012 US$) in Iran in 1997 to that in 2002?
Provide a short and direct response. 1.53. What is the ratio of the Aid received (constant 2012 US$) in Slovak Republic in 1997 to that in 2002?
Your response must be concise. 0.41. What is the ratio of the Aid received (constant 2012 US$) of Algeria in 1997 to that in 2003?
Ensure brevity in your answer.  1.15. What is the ratio of the Aid received (constant 2012 US$) of Iran in 1997 to that in 2003?
Make the answer very short. 1.54. What is the ratio of the Aid received (constant 2012 US$) of Slovak Republic in 1997 to that in 2003?
Your response must be concise. 0.44. What is the ratio of the Aid received (constant 2012 US$) of Algeria in 1998 to that in 1999?
Give a very brief answer. 2.92. What is the ratio of the Aid received (constant 2012 US$) in Iran in 1998 to that in 1999?
Give a very brief answer. 1.03. What is the ratio of the Aid received (constant 2012 US$) in Slovak Republic in 1998 to that in 1999?
Keep it short and to the point. 0.47. What is the ratio of the Aid received (constant 2012 US$) of Algeria in 1998 to that in 2000?
Provide a succinct answer. 1.86. What is the ratio of the Aid received (constant 2012 US$) of Iran in 1998 to that in 2000?
Your answer should be very brief. 1.17. What is the ratio of the Aid received (constant 2012 US$) in Slovak Republic in 1998 to that in 2000?
Offer a very short reply. 1.17. What is the ratio of the Aid received (constant 2012 US$) in Algeria in 1998 to that in 2001?
Provide a short and direct response. 1.81. What is the ratio of the Aid received (constant 2012 US$) of Iran in 1998 to that in 2001?
Your response must be concise. 1.25. What is the ratio of the Aid received (constant 2012 US$) of Slovak Republic in 1998 to that in 2001?
Offer a very short reply. 0.8. What is the ratio of the Aid received (constant 2012 US$) in Algeria in 1998 to that in 2002?
Your answer should be compact. 2. What is the ratio of the Aid received (constant 2012 US$) of Iran in 1998 to that in 2002?
Ensure brevity in your answer.  1.27. What is the ratio of the Aid received (constant 2012 US$) in Slovak Republic in 1998 to that in 2002?
Your answer should be compact. 0.92. What is the ratio of the Aid received (constant 2012 US$) of Algeria in 1998 to that in 2003?
Your response must be concise. 1.94. What is the ratio of the Aid received (constant 2012 US$) of Slovak Republic in 1998 to that in 2003?
Give a very brief answer. 0.99. What is the ratio of the Aid received (constant 2012 US$) of Algeria in 1999 to that in 2000?
Offer a terse response. 0.64. What is the ratio of the Aid received (constant 2012 US$) in Iran in 1999 to that in 2000?
Your response must be concise. 1.14. What is the ratio of the Aid received (constant 2012 US$) in Slovak Republic in 1999 to that in 2000?
Give a very brief answer. 2.49. What is the ratio of the Aid received (constant 2012 US$) in Algeria in 1999 to that in 2001?
Your response must be concise. 0.62. What is the ratio of the Aid received (constant 2012 US$) in Iran in 1999 to that in 2001?
Your response must be concise. 1.22. What is the ratio of the Aid received (constant 2012 US$) of Slovak Republic in 1999 to that in 2001?
Offer a very short reply. 1.7. What is the ratio of the Aid received (constant 2012 US$) of Algeria in 1999 to that in 2002?
Offer a very short reply. 0.69. What is the ratio of the Aid received (constant 2012 US$) of Iran in 1999 to that in 2002?
Your response must be concise. 1.24. What is the ratio of the Aid received (constant 2012 US$) of Slovak Republic in 1999 to that in 2002?
Your answer should be very brief. 1.96. What is the ratio of the Aid received (constant 2012 US$) of Algeria in 1999 to that in 2003?
Your response must be concise. 0.66. What is the ratio of the Aid received (constant 2012 US$) in Iran in 1999 to that in 2003?
Your answer should be compact. 1.25. What is the ratio of the Aid received (constant 2012 US$) of Slovak Republic in 1999 to that in 2003?
Your response must be concise. 2.1. What is the ratio of the Aid received (constant 2012 US$) in Algeria in 2000 to that in 2001?
Your response must be concise. 0.97. What is the ratio of the Aid received (constant 2012 US$) of Iran in 2000 to that in 2001?
Your response must be concise. 1.07. What is the ratio of the Aid received (constant 2012 US$) of Slovak Republic in 2000 to that in 2001?
Your answer should be very brief. 0.68. What is the ratio of the Aid received (constant 2012 US$) in Algeria in 2000 to that in 2002?
Your answer should be very brief. 1.07. What is the ratio of the Aid received (constant 2012 US$) in Iran in 2000 to that in 2002?
Provide a short and direct response. 1.09. What is the ratio of the Aid received (constant 2012 US$) of Slovak Republic in 2000 to that in 2002?
Keep it short and to the point. 0.79. What is the ratio of the Aid received (constant 2012 US$) in Algeria in 2000 to that in 2003?
Provide a succinct answer. 1.04. What is the ratio of the Aid received (constant 2012 US$) in Iran in 2000 to that in 2003?
Keep it short and to the point. 1.1. What is the ratio of the Aid received (constant 2012 US$) in Slovak Republic in 2000 to that in 2003?
Your response must be concise. 0.84. What is the ratio of the Aid received (constant 2012 US$) in Algeria in 2001 to that in 2002?
Make the answer very short. 1.11. What is the ratio of the Aid received (constant 2012 US$) of Iran in 2001 to that in 2002?
Provide a succinct answer. 1.02. What is the ratio of the Aid received (constant 2012 US$) of Slovak Republic in 2001 to that in 2002?
Keep it short and to the point. 1.15. What is the ratio of the Aid received (constant 2012 US$) of Algeria in 2001 to that in 2003?
Offer a very short reply. 1.07. What is the ratio of the Aid received (constant 2012 US$) in Slovak Republic in 2001 to that in 2003?
Ensure brevity in your answer.  1.23. What is the ratio of the Aid received (constant 2012 US$) in Iran in 2002 to that in 2003?
Provide a succinct answer. 1.01. What is the ratio of the Aid received (constant 2012 US$) in Slovak Republic in 2002 to that in 2003?
Give a very brief answer. 1.07. What is the difference between the highest and the second highest Aid received (constant 2012 US$) of Algeria?
Give a very brief answer. 2.12e+08. What is the difference between the highest and the second highest Aid received (constant 2012 US$) in Iran?
Provide a short and direct response. 4.51e+07. What is the difference between the highest and the second highest Aid received (constant 2012 US$) of Slovak Republic?
Your answer should be compact. 1.98e+08. What is the difference between the highest and the lowest Aid received (constant 2012 US$) of Algeria?
Keep it short and to the point. 4.05e+08. What is the difference between the highest and the lowest Aid received (constant 2012 US$) of Iran?
Offer a terse response. 9.55e+07. What is the difference between the highest and the lowest Aid received (constant 2012 US$) of Slovak Republic?
Offer a very short reply. 3.78e+08. 